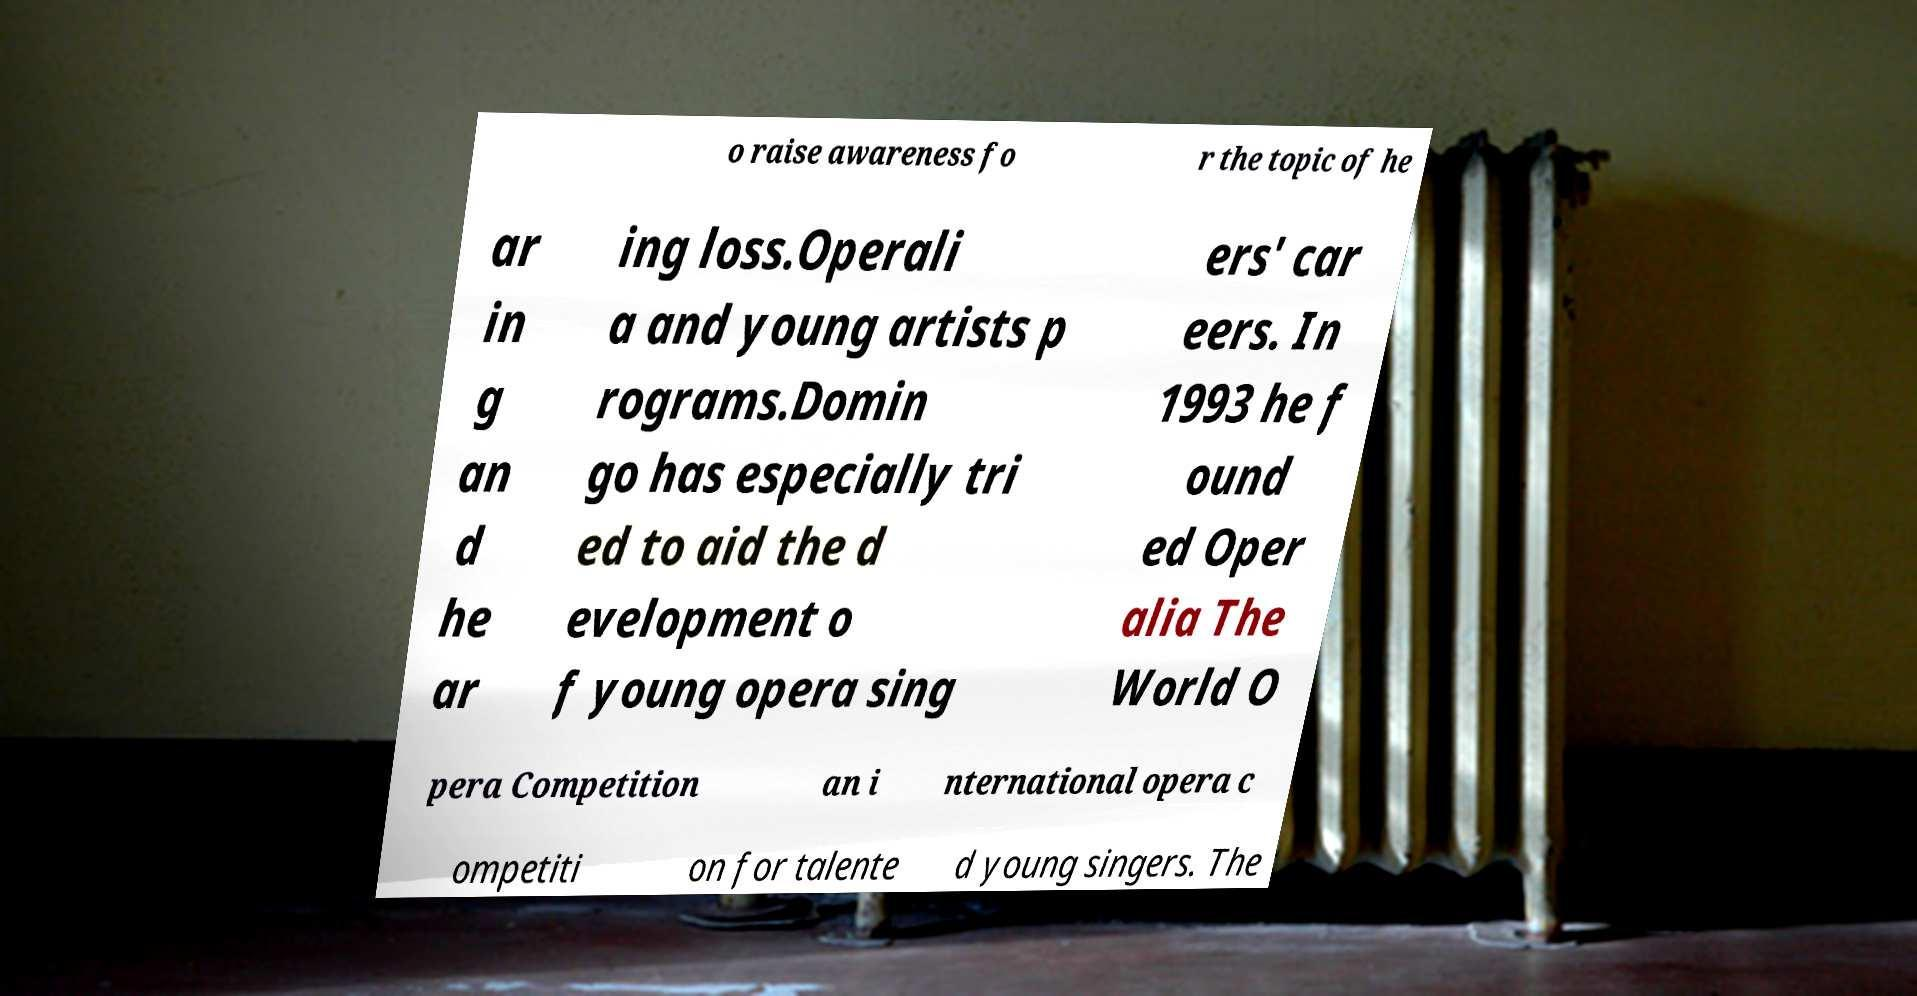Please identify and transcribe the text found in this image. o raise awareness fo r the topic of he ar in g an d he ar ing loss.Operali a and young artists p rograms.Domin go has especially tri ed to aid the d evelopment o f young opera sing ers' car eers. In 1993 he f ound ed Oper alia The World O pera Competition an i nternational opera c ompetiti on for talente d young singers. The 